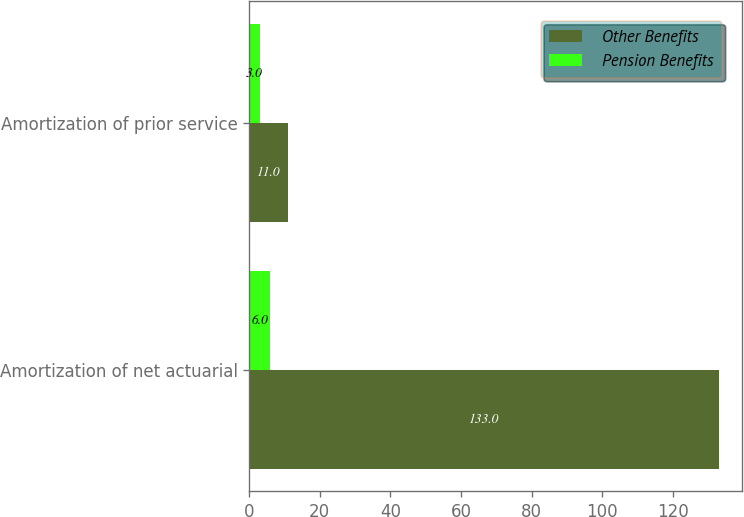<chart> <loc_0><loc_0><loc_500><loc_500><stacked_bar_chart><ecel><fcel>Amortization of net actuarial<fcel>Amortization of prior service<nl><fcel>Other Benefits<fcel>133<fcel>11<nl><fcel>Pension Benefits<fcel>6<fcel>3<nl></chart> 